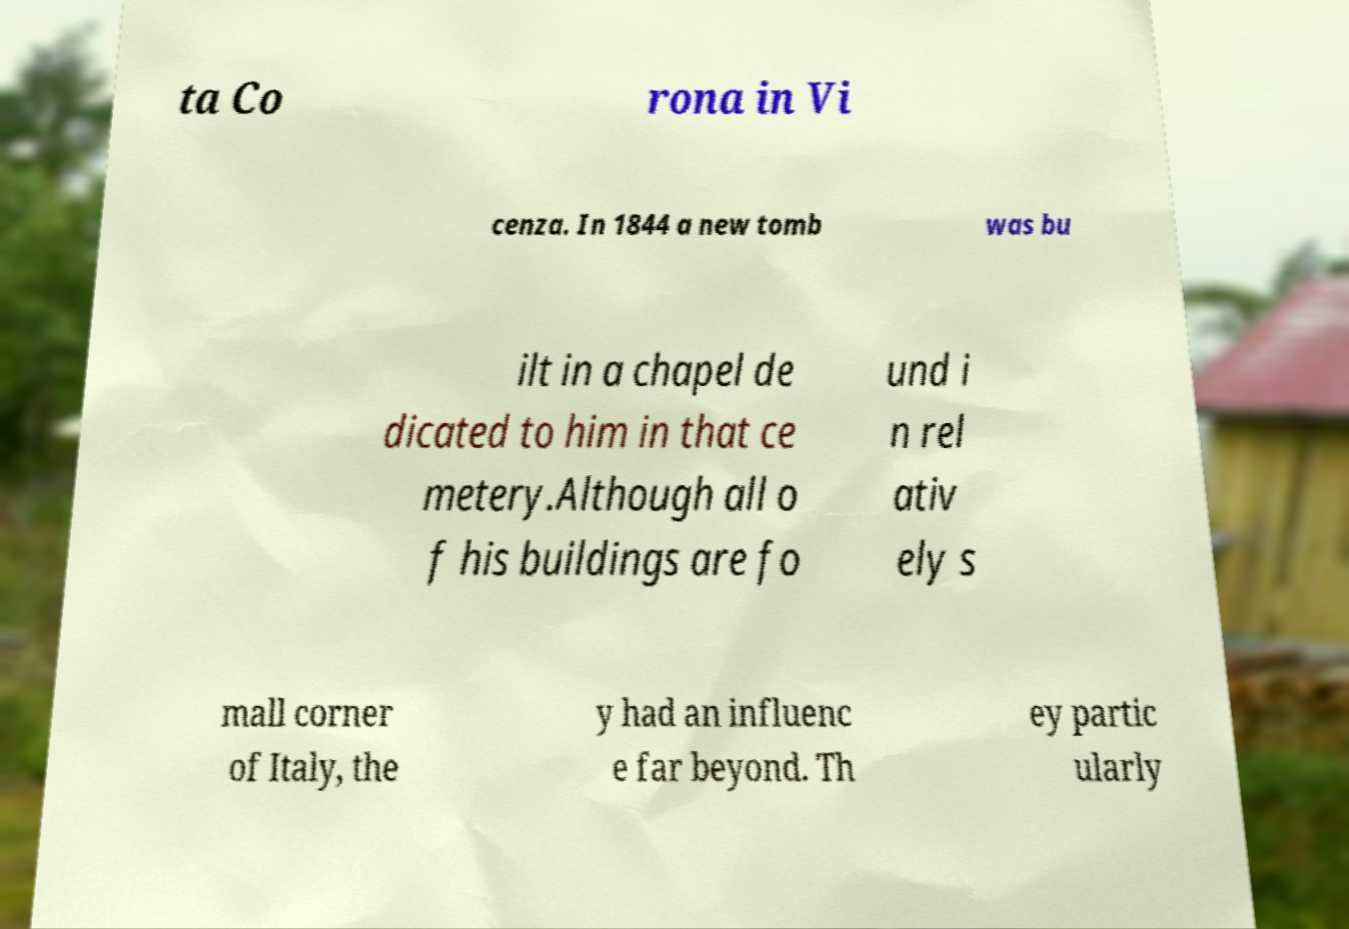For documentation purposes, I need the text within this image transcribed. Could you provide that? ta Co rona in Vi cenza. In 1844 a new tomb was bu ilt in a chapel de dicated to him in that ce metery.Although all o f his buildings are fo und i n rel ativ ely s mall corner of Italy, the y had an influenc e far beyond. Th ey partic ularly 